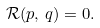<formula> <loc_0><loc_0><loc_500><loc_500>\mathcal { R } ( p , \, q ) = 0 .</formula> 